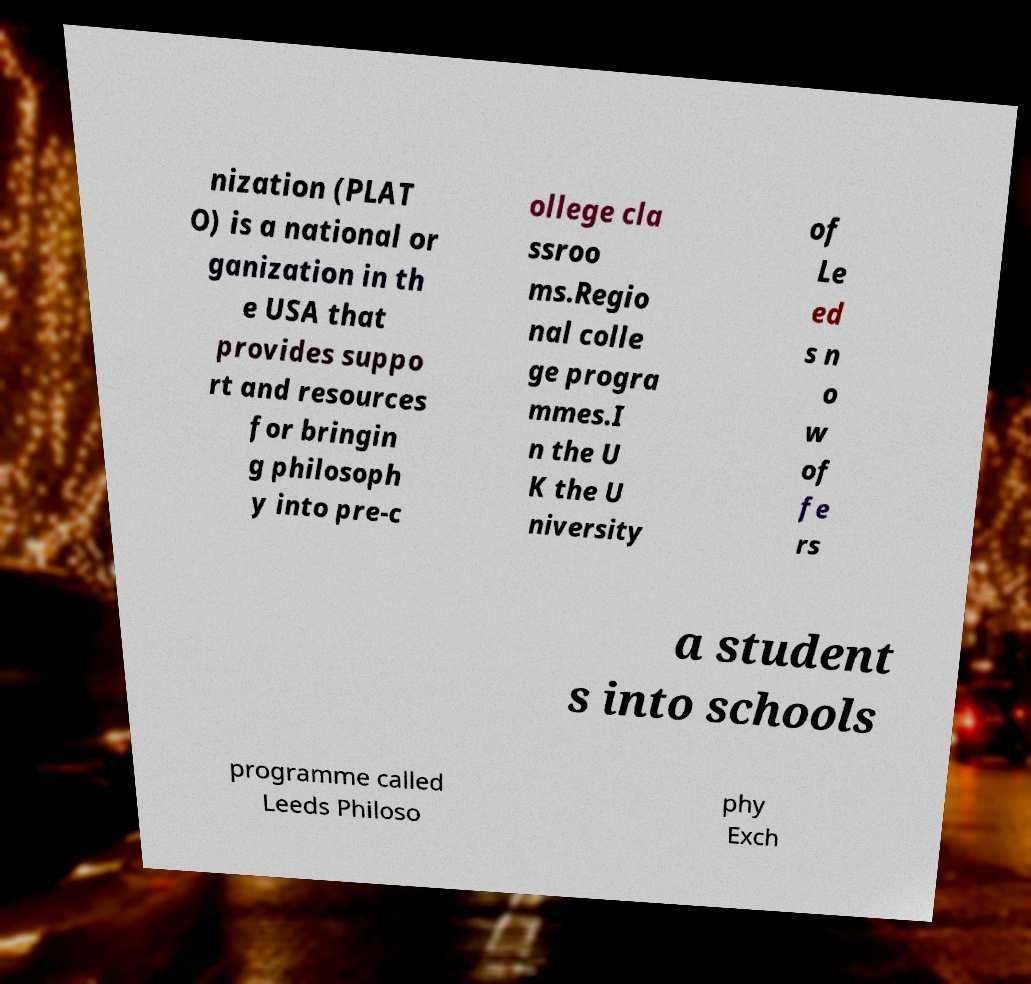What messages or text are displayed in this image? I need them in a readable, typed format. nization (PLAT O) is a national or ganization in th e USA that provides suppo rt and resources for bringin g philosoph y into pre-c ollege cla ssroo ms.Regio nal colle ge progra mmes.I n the U K the U niversity of Le ed s n o w of fe rs a student s into schools programme called Leeds Philoso phy Exch 